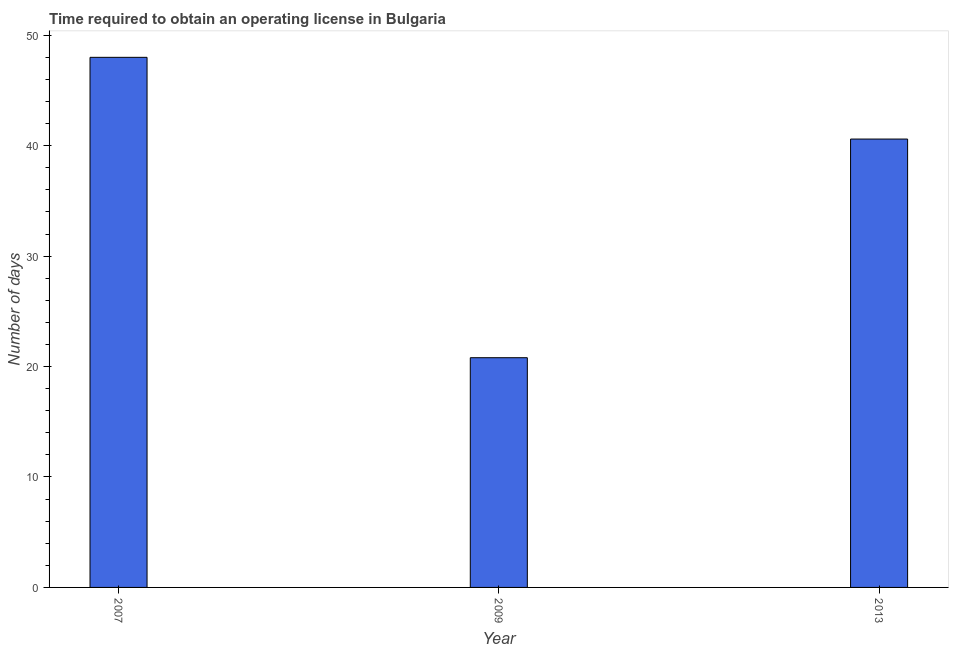Does the graph contain any zero values?
Offer a terse response. No. What is the title of the graph?
Give a very brief answer. Time required to obtain an operating license in Bulgaria. What is the label or title of the Y-axis?
Your answer should be compact. Number of days. What is the number of days to obtain operating license in 2009?
Keep it short and to the point. 20.8. Across all years, what is the maximum number of days to obtain operating license?
Your answer should be compact. 48. Across all years, what is the minimum number of days to obtain operating license?
Offer a very short reply. 20.8. In which year was the number of days to obtain operating license maximum?
Offer a very short reply. 2007. In which year was the number of days to obtain operating license minimum?
Make the answer very short. 2009. What is the sum of the number of days to obtain operating license?
Offer a very short reply. 109.4. What is the difference between the number of days to obtain operating license in 2007 and 2013?
Your response must be concise. 7.4. What is the average number of days to obtain operating license per year?
Offer a very short reply. 36.47. What is the median number of days to obtain operating license?
Your answer should be compact. 40.6. What is the ratio of the number of days to obtain operating license in 2007 to that in 2009?
Give a very brief answer. 2.31. Is the difference between the number of days to obtain operating license in 2007 and 2013 greater than the difference between any two years?
Offer a terse response. No. What is the difference between the highest and the lowest number of days to obtain operating license?
Make the answer very short. 27.2. How many bars are there?
Provide a short and direct response. 3. Are the values on the major ticks of Y-axis written in scientific E-notation?
Your response must be concise. No. What is the Number of days in 2009?
Your answer should be very brief. 20.8. What is the Number of days of 2013?
Your answer should be very brief. 40.6. What is the difference between the Number of days in 2007 and 2009?
Your answer should be very brief. 27.2. What is the difference between the Number of days in 2009 and 2013?
Offer a very short reply. -19.8. What is the ratio of the Number of days in 2007 to that in 2009?
Offer a terse response. 2.31. What is the ratio of the Number of days in 2007 to that in 2013?
Provide a short and direct response. 1.18. What is the ratio of the Number of days in 2009 to that in 2013?
Your answer should be compact. 0.51. 